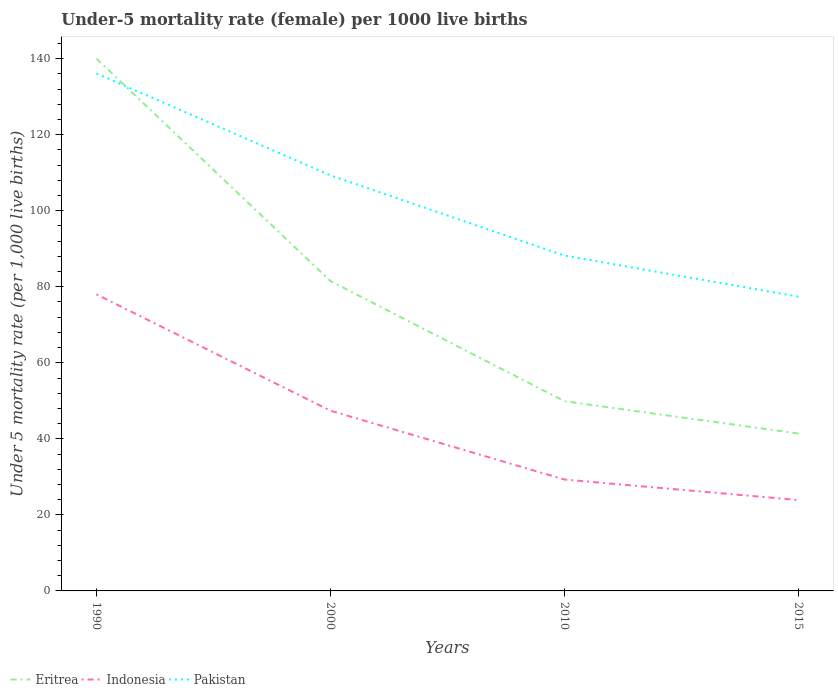Is the number of lines equal to the number of legend labels?
Your answer should be very brief. Yes. Across all years, what is the maximum under-five mortality rate in Indonesia?
Your answer should be very brief. 23.9. In which year was the under-five mortality rate in Eritrea maximum?
Provide a succinct answer. 2015. What is the total under-five mortality rate in Indonesia in the graph?
Provide a short and direct response. 54.1. What is the difference between the highest and the second highest under-five mortality rate in Eritrea?
Keep it short and to the point. 98.6. What is the difference between the highest and the lowest under-five mortality rate in Eritrea?
Your answer should be very brief. 2. How many lines are there?
Make the answer very short. 3. How many legend labels are there?
Offer a terse response. 3. How are the legend labels stacked?
Your answer should be very brief. Horizontal. What is the title of the graph?
Your answer should be very brief. Under-5 mortality rate (female) per 1000 live births. Does "Costa Rica" appear as one of the legend labels in the graph?
Offer a terse response. No. What is the label or title of the Y-axis?
Make the answer very short. Under 5 mortality rate (per 1,0 live births). What is the Under 5 mortality rate (per 1,000 live births) in Eritrea in 1990?
Give a very brief answer. 140. What is the Under 5 mortality rate (per 1,000 live births) in Pakistan in 1990?
Make the answer very short. 136.1. What is the Under 5 mortality rate (per 1,000 live births) in Eritrea in 2000?
Make the answer very short. 81.5. What is the Under 5 mortality rate (per 1,000 live births) in Indonesia in 2000?
Keep it short and to the point. 47.4. What is the Under 5 mortality rate (per 1,000 live births) in Pakistan in 2000?
Give a very brief answer. 109.3. What is the Under 5 mortality rate (per 1,000 live births) in Eritrea in 2010?
Your response must be concise. 49.9. What is the Under 5 mortality rate (per 1,000 live births) in Indonesia in 2010?
Give a very brief answer. 29.3. What is the Under 5 mortality rate (per 1,000 live births) in Pakistan in 2010?
Provide a short and direct response. 88.2. What is the Under 5 mortality rate (per 1,000 live births) of Eritrea in 2015?
Your response must be concise. 41.4. What is the Under 5 mortality rate (per 1,000 live births) in Indonesia in 2015?
Your answer should be compact. 23.9. What is the Under 5 mortality rate (per 1,000 live births) of Pakistan in 2015?
Your response must be concise. 77.4. Across all years, what is the maximum Under 5 mortality rate (per 1,000 live births) of Eritrea?
Provide a succinct answer. 140. Across all years, what is the maximum Under 5 mortality rate (per 1,000 live births) of Pakistan?
Make the answer very short. 136.1. Across all years, what is the minimum Under 5 mortality rate (per 1,000 live births) in Eritrea?
Keep it short and to the point. 41.4. Across all years, what is the minimum Under 5 mortality rate (per 1,000 live births) of Indonesia?
Make the answer very short. 23.9. Across all years, what is the minimum Under 5 mortality rate (per 1,000 live births) of Pakistan?
Offer a terse response. 77.4. What is the total Under 5 mortality rate (per 1,000 live births) of Eritrea in the graph?
Offer a very short reply. 312.8. What is the total Under 5 mortality rate (per 1,000 live births) of Indonesia in the graph?
Offer a terse response. 178.6. What is the total Under 5 mortality rate (per 1,000 live births) in Pakistan in the graph?
Ensure brevity in your answer.  411. What is the difference between the Under 5 mortality rate (per 1,000 live births) of Eritrea in 1990 and that in 2000?
Keep it short and to the point. 58.5. What is the difference between the Under 5 mortality rate (per 1,000 live births) in Indonesia in 1990 and that in 2000?
Your answer should be very brief. 30.6. What is the difference between the Under 5 mortality rate (per 1,000 live births) of Pakistan in 1990 and that in 2000?
Keep it short and to the point. 26.8. What is the difference between the Under 5 mortality rate (per 1,000 live births) of Eritrea in 1990 and that in 2010?
Your response must be concise. 90.1. What is the difference between the Under 5 mortality rate (per 1,000 live births) in Indonesia in 1990 and that in 2010?
Make the answer very short. 48.7. What is the difference between the Under 5 mortality rate (per 1,000 live births) of Pakistan in 1990 and that in 2010?
Provide a short and direct response. 47.9. What is the difference between the Under 5 mortality rate (per 1,000 live births) of Eritrea in 1990 and that in 2015?
Provide a succinct answer. 98.6. What is the difference between the Under 5 mortality rate (per 1,000 live births) in Indonesia in 1990 and that in 2015?
Provide a succinct answer. 54.1. What is the difference between the Under 5 mortality rate (per 1,000 live births) of Pakistan in 1990 and that in 2015?
Provide a succinct answer. 58.7. What is the difference between the Under 5 mortality rate (per 1,000 live births) of Eritrea in 2000 and that in 2010?
Your answer should be very brief. 31.6. What is the difference between the Under 5 mortality rate (per 1,000 live births) of Pakistan in 2000 and that in 2010?
Your response must be concise. 21.1. What is the difference between the Under 5 mortality rate (per 1,000 live births) of Eritrea in 2000 and that in 2015?
Keep it short and to the point. 40.1. What is the difference between the Under 5 mortality rate (per 1,000 live births) in Indonesia in 2000 and that in 2015?
Ensure brevity in your answer.  23.5. What is the difference between the Under 5 mortality rate (per 1,000 live births) of Pakistan in 2000 and that in 2015?
Your answer should be compact. 31.9. What is the difference between the Under 5 mortality rate (per 1,000 live births) in Eritrea in 2010 and that in 2015?
Your response must be concise. 8.5. What is the difference between the Under 5 mortality rate (per 1,000 live births) in Eritrea in 1990 and the Under 5 mortality rate (per 1,000 live births) in Indonesia in 2000?
Make the answer very short. 92.6. What is the difference between the Under 5 mortality rate (per 1,000 live births) of Eritrea in 1990 and the Under 5 mortality rate (per 1,000 live births) of Pakistan in 2000?
Give a very brief answer. 30.7. What is the difference between the Under 5 mortality rate (per 1,000 live births) in Indonesia in 1990 and the Under 5 mortality rate (per 1,000 live births) in Pakistan in 2000?
Provide a short and direct response. -31.3. What is the difference between the Under 5 mortality rate (per 1,000 live births) in Eritrea in 1990 and the Under 5 mortality rate (per 1,000 live births) in Indonesia in 2010?
Provide a succinct answer. 110.7. What is the difference between the Under 5 mortality rate (per 1,000 live births) in Eritrea in 1990 and the Under 5 mortality rate (per 1,000 live births) in Pakistan in 2010?
Your answer should be very brief. 51.8. What is the difference between the Under 5 mortality rate (per 1,000 live births) of Eritrea in 1990 and the Under 5 mortality rate (per 1,000 live births) of Indonesia in 2015?
Provide a short and direct response. 116.1. What is the difference between the Under 5 mortality rate (per 1,000 live births) in Eritrea in 1990 and the Under 5 mortality rate (per 1,000 live births) in Pakistan in 2015?
Provide a short and direct response. 62.6. What is the difference between the Under 5 mortality rate (per 1,000 live births) in Indonesia in 1990 and the Under 5 mortality rate (per 1,000 live births) in Pakistan in 2015?
Your response must be concise. 0.6. What is the difference between the Under 5 mortality rate (per 1,000 live births) of Eritrea in 2000 and the Under 5 mortality rate (per 1,000 live births) of Indonesia in 2010?
Provide a short and direct response. 52.2. What is the difference between the Under 5 mortality rate (per 1,000 live births) in Eritrea in 2000 and the Under 5 mortality rate (per 1,000 live births) in Pakistan in 2010?
Keep it short and to the point. -6.7. What is the difference between the Under 5 mortality rate (per 1,000 live births) in Indonesia in 2000 and the Under 5 mortality rate (per 1,000 live births) in Pakistan in 2010?
Make the answer very short. -40.8. What is the difference between the Under 5 mortality rate (per 1,000 live births) of Eritrea in 2000 and the Under 5 mortality rate (per 1,000 live births) of Indonesia in 2015?
Your answer should be compact. 57.6. What is the difference between the Under 5 mortality rate (per 1,000 live births) in Eritrea in 2010 and the Under 5 mortality rate (per 1,000 live births) in Indonesia in 2015?
Provide a short and direct response. 26. What is the difference between the Under 5 mortality rate (per 1,000 live births) of Eritrea in 2010 and the Under 5 mortality rate (per 1,000 live births) of Pakistan in 2015?
Offer a terse response. -27.5. What is the difference between the Under 5 mortality rate (per 1,000 live births) in Indonesia in 2010 and the Under 5 mortality rate (per 1,000 live births) in Pakistan in 2015?
Your answer should be very brief. -48.1. What is the average Under 5 mortality rate (per 1,000 live births) of Eritrea per year?
Your answer should be compact. 78.2. What is the average Under 5 mortality rate (per 1,000 live births) of Indonesia per year?
Provide a short and direct response. 44.65. What is the average Under 5 mortality rate (per 1,000 live births) of Pakistan per year?
Offer a very short reply. 102.75. In the year 1990, what is the difference between the Under 5 mortality rate (per 1,000 live births) in Eritrea and Under 5 mortality rate (per 1,000 live births) in Pakistan?
Your answer should be compact. 3.9. In the year 1990, what is the difference between the Under 5 mortality rate (per 1,000 live births) of Indonesia and Under 5 mortality rate (per 1,000 live births) of Pakistan?
Your answer should be compact. -58.1. In the year 2000, what is the difference between the Under 5 mortality rate (per 1,000 live births) in Eritrea and Under 5 mortality rate (per 1,000 live births) in Indonesia?
Offer a terse response. 34.1. In the year 2000, what is the difference between the Under 5 mortality rate (per 1,000 live births) of Eritrea and Under 5 mortality rate (per 1,000 live births) of Pakistan?
Offer a very short reply. -27.8. In the year 2000, what is the difference between the Under 5 mortality rate (per 1,000 live births) in Indonesia and Under 5 mortality rate (per 1,000 live births) in Pakistan?
Offer a terse response. -61.9. In the year 2010, what is the difference between the Under 5 mortality rate (per 1,000 live births) in Eritrea and Under 5 mortality rate (per 1,000 live births) in Indonesia?
Provide a short and direct response. 20.6. In the year 2010, what is the difference between the Under 5 mortality rate (per 1,000 live births) in Eritrea and Under 5 mortality rate (per 1,000 live births) in Pakistan?
Provide a short and direct response. -38.3. In the year 2010, what is the difference between the Under 5 mortality rate (per 1,000 live births) of Indonesia and Under 5 mortality rate (per 1,000 live births) of Pakistan?
Give a very brief answer. -58.9. In the year 2015, what is the difference between the Under 5 mortality rate (per 1,000 live births) in Eritrea and Under 5 mortality rate (per 1,000 live births) in Pakistan?
Your answer should be very brief. -36. In the year 2015, what is the difference between the Under 5 mortality rate (per 1,000 live births) in Indonesia and Under 5 mortality rate (per 1,000 live births) in Pakistan?
Provide a short and direct response. -53.5. What is the ratio of the Under 5 mortality rate (per 1,000 live births) in Eritrea in 1990 to that in 2000?
Ensure brevity in your answer.  1.72. What is the ratio of the Under 5 mortality rate (per 1,000 live births) in Indonesia in 1990 to that in 2000?
Your answer should be compact. 1.65. What is the ratio of the Under 5 mortality rate (per 1,000 live births) of Pakistan in 1990 to that in 2000?
Offer a very short reply. 1.25. What is the ratio of the Under 5 mortality rate (per 1,000 live births) of Eritrea in 1990 to that in 2010?
Your response must be concise. 2.81. What is the ratio of the Under 5 mortality rate (per 1,000 live births) of Indonesia in 1990 to that in 2010?
Make the answer very short. 2.66. What is the ratio of the Under 5 mortality rate (per 1,000 live births) in Pakistan in 1990 to that in 2010?
Give a very brief answer. 1.54. What is the ratio of the Under 5 mortality rate (per 1,000 live births) of Eritrea in 1990 to that in 2015?
Your response must be concise. 3.38. What is the ratio of the Under 5 mortality rate (per 1,000 live births) of Indonesia in 1990 to that in 2015?
Give a very brief answer. 3.26. What is the ratio of the Under 5 mortality rate (per 1,000 live births) in Pakistan in 1990 to that in 2015?
Your answer should be compact. 1.76. What is the ratio of the Under 5 mortality rate (per 1,000 live births) of Eritrea in 2000 to that in 2010?
Offer a very short reply. 1.63. What is the ratio of the Under 5 mortality rate (per 1,000 live births) in Indonesia in 2000 to that in 2010?
Ensure brevity in your answer.  1.62. What is the ratio of the Under 5 mortality rate (per 1,000 live births) in Pakistan in 2000 to that in 2010?
Your answer should be very brief. 1.24. What is the ratio of the Under 5 mortality rate (per 1,000 live births) in Eritrea in 2000 to that in 2015?
Keep it short and to the point. 1.97. What is the ratio of the Under 5 mortality rate (per 1,000 live births) of Indonesia in 2000 to that in 2015?
Ensure brevity in your answer.  1.98. What is the ratio of the Under 5 mortality rate (per 1,000 live births) of Pakistan in 2000 to that in 2015?
Make the answer very short. 1.41. What is the ratio of the Under 5 mortality rate (per 1,000 live births) of Eritrea in 2010 to that in 2015?
Provide a succinct answer. 1.21. What is the ratio of the Under 5 mortality rate (per 1,000 live births) of Indonesia in 2010 to that in 2015?
Offer a terse response. 1.23. What is the ratio of the Under 5 mortality rate (per 1,000 live births) of Pakistan in 2010 to that in 2015?
Provide a short and direct response. 1.14. What is the difference between the highest and the second highest Under 5 mortality rate (per 1,000 live births) of Eritrea?
Keep it short and to the point. 58.5. What is the difference between the highest and the second highest Under 5 mortality rate (per 1,000 live births) in Indonesia?
Your answer should be compact. 30.6. What is the difference between the highest and the second highest Under 5 mortality rate (per 1,000 live births) in Pakistan?
Provide a succinct answer. 26.8. What is the difference between the highest and the lowest Under 5 mortality rate (per 1,000 live births) in Eritrea?
Provide a succinct answer. 98.6. What is the difference between the highest and the lowest Under 5 mortality rate (per 1,000 live births) in Indonesia?
Ensure brevity in your answer.  54.1. What is the difference between the highest and the lowest Under 5 mortality rate (per 1,000 live births) of Pakistan?
Your response must be concise. 58.7. 